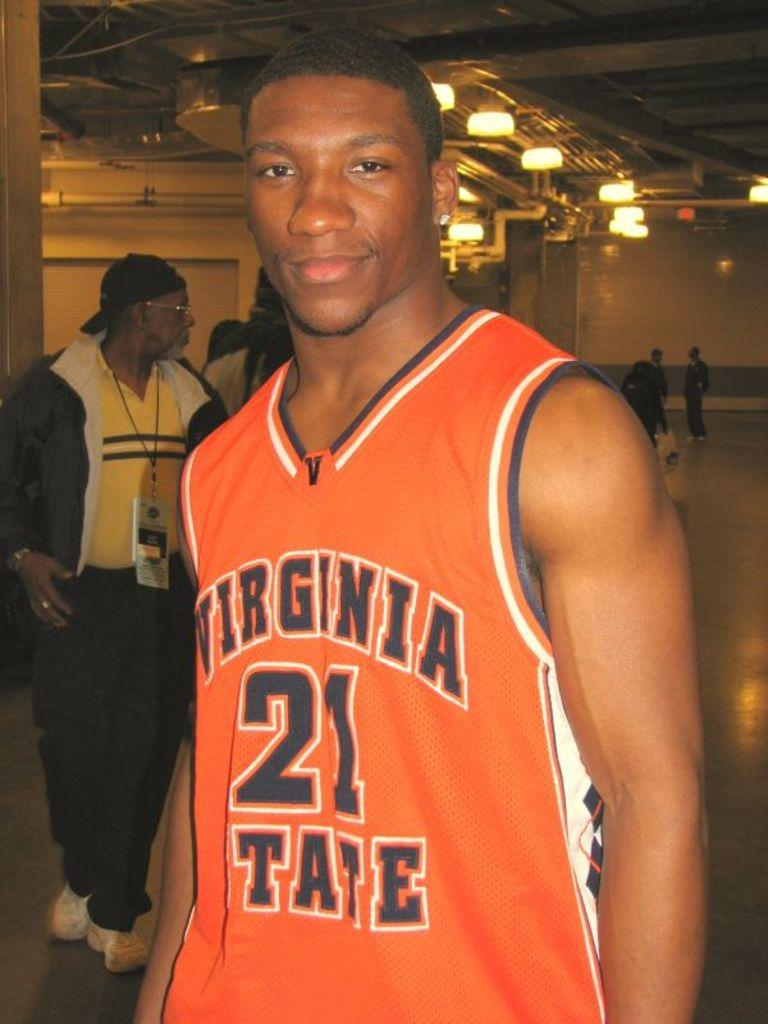<image>
Render a clear and concise summary of the photo. an orange jersey that has the number 21 on it 